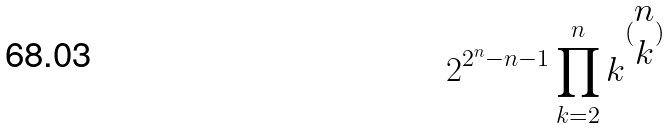Convert formula to latex. <formula><loc_0><loc_0><loc_500><loc_500>2 ^ { 2 ^ { n } - n - 1 } \prod _ { k = 2 } ^ { n } k ^ { ( \begin{matrix} n \\ k \end{matrix} ) }</formula> 